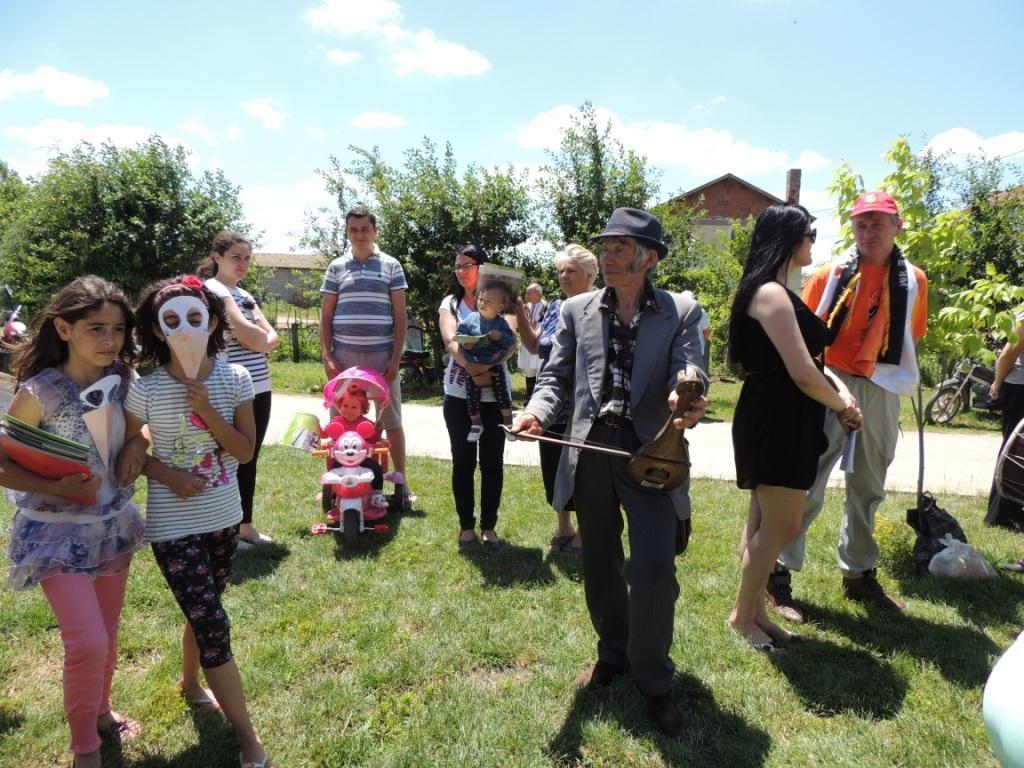Describe this image in one or two sentences. In this image I can see the group of people with different color dresses and I can see one person sitting on the toy vehicle. And I can see two people with the cap and hat. In the background there are many trees, sheds, clouds and sky. 